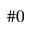<formula> <loc_0><loc_0><loc_500><loc_500>\# 0</formula> 